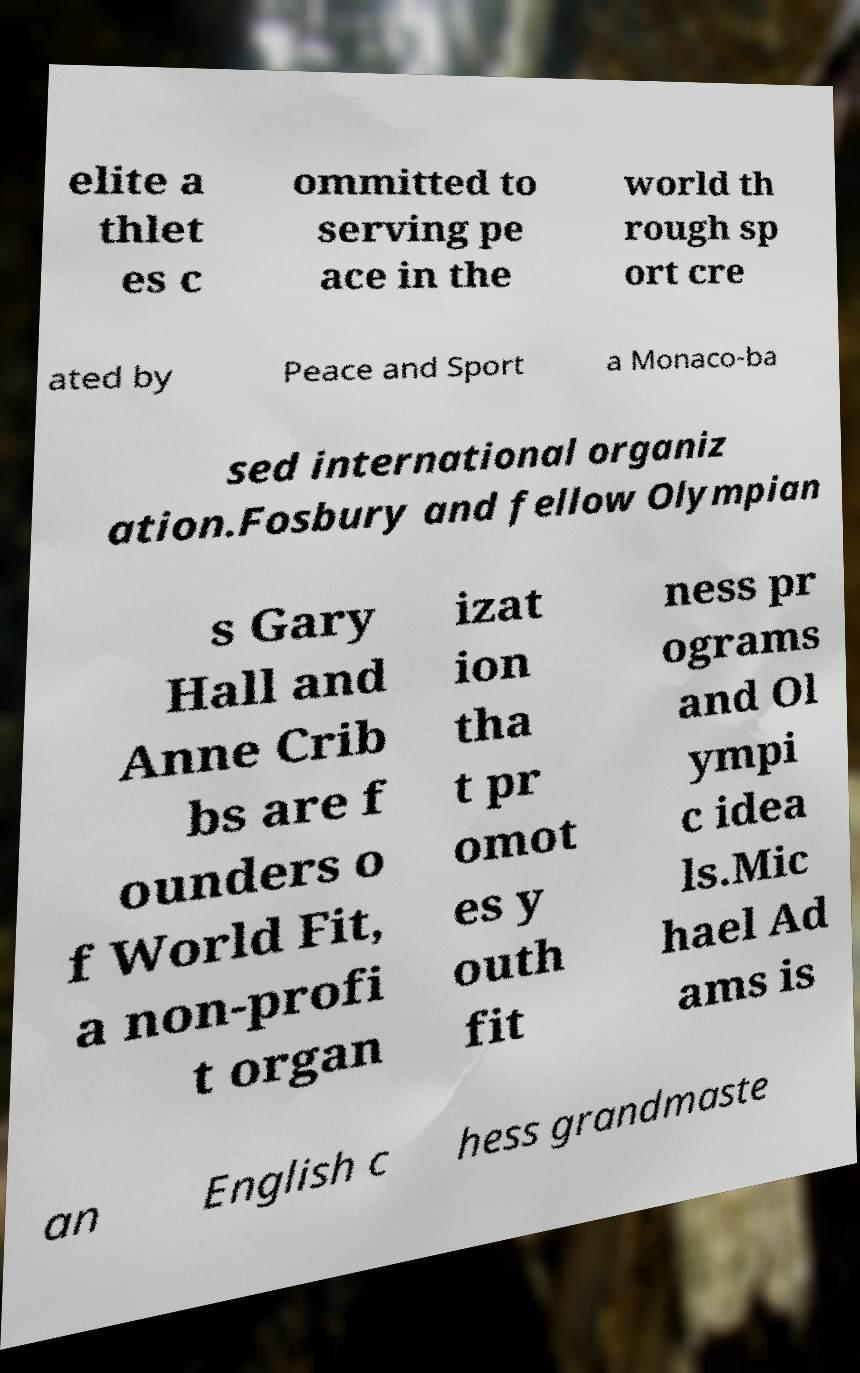Please read and relay the text visible in this image. What does it say? elite a thlet es c ommitted to serving pe ace in the world th rough sp ort cre ated by Peace and Sport a Monaco-ba sed international organiz ation.Fosbury and fellow Olympian s Gary Hall and Anne Crib bs are f ounders o f World Fit, a non-profi t organ izat ion tha t pr omot es y outh fit ness pr ograms and Ol ympi c idea ls.Mic hael Ad ams is an English c hess grandmaste 